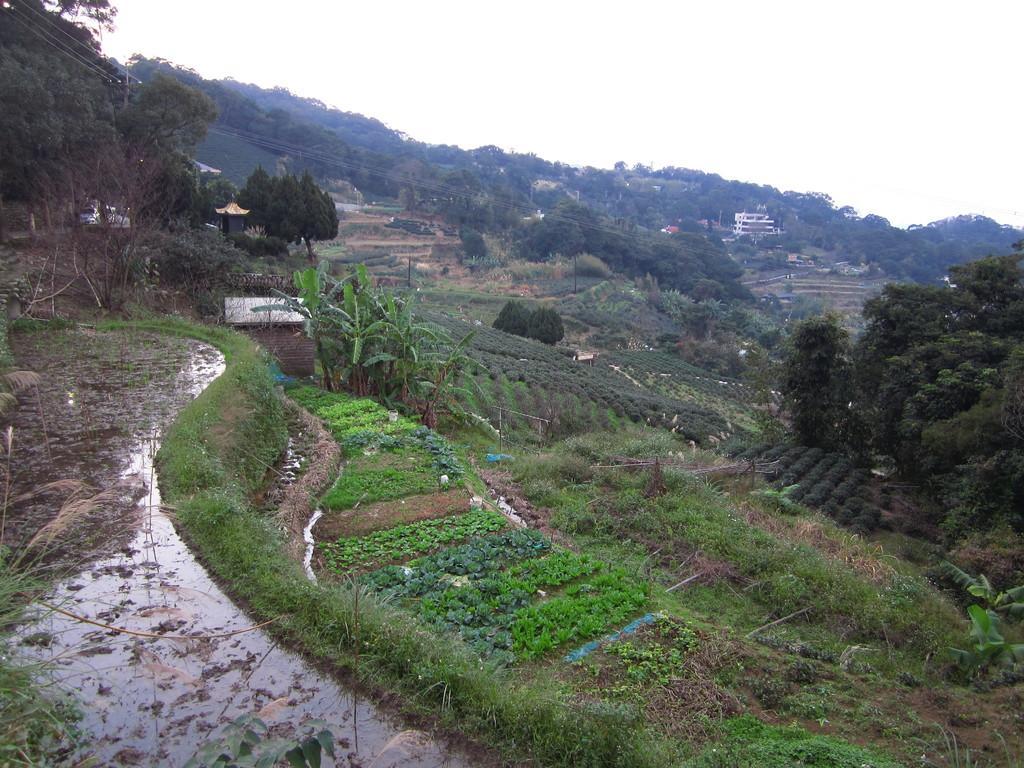How would you summarize this image in a sentence or two? In this image we can see a group of plants, grass, water, a house, some wooden poles and a group of trees. We can also see some buildings, an utility pole with wires and the sky which looks cloudy. 